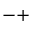<formula> <loc_0><loc_0><loc_500><loc_500>- +</formula> 